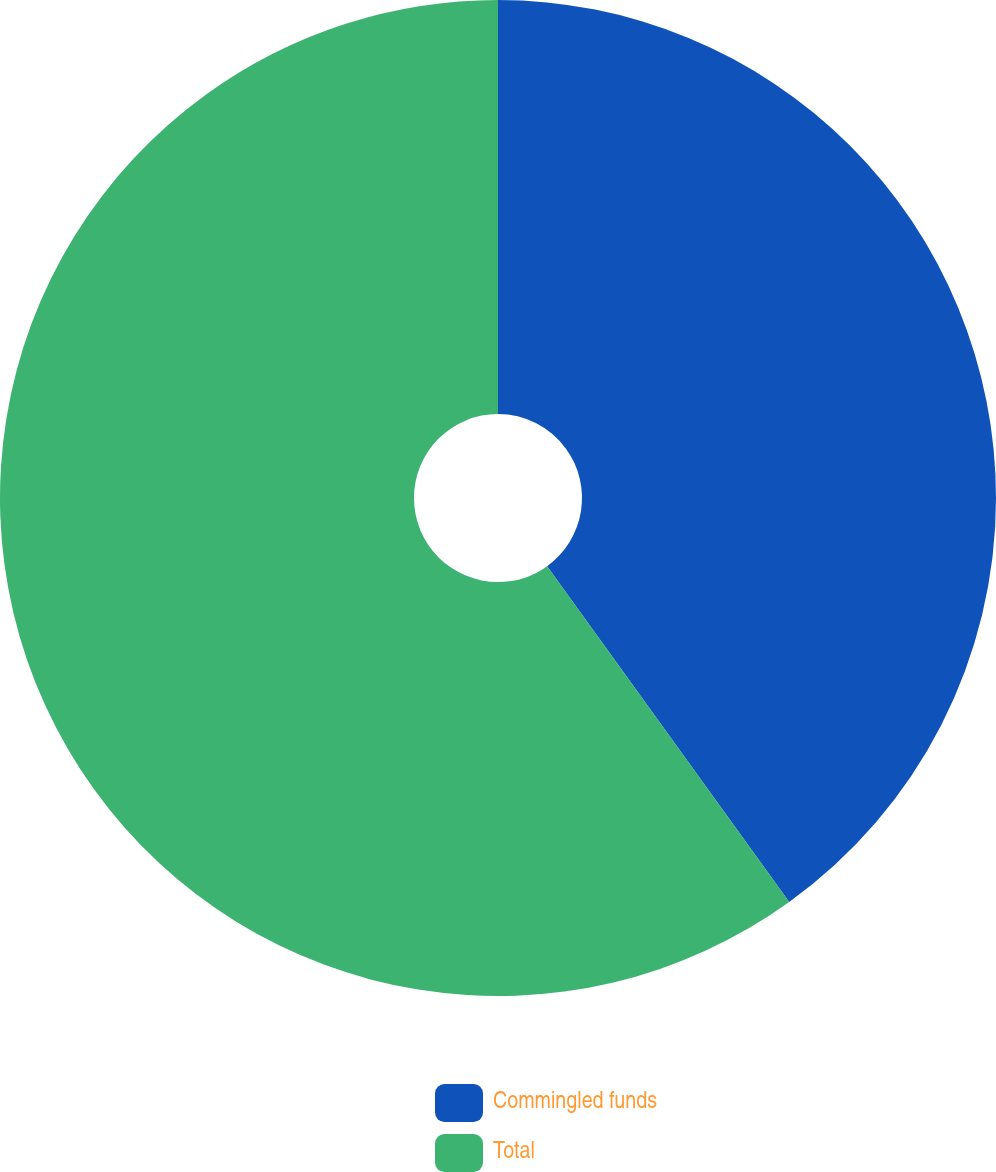<chart> <loc_0><loc_0><loc_500><loc_500><pie_chart><fcel>Commingled funds<fcel>Total<nl><fcel>40.06%<fcel>59.94%<nl></chart> 